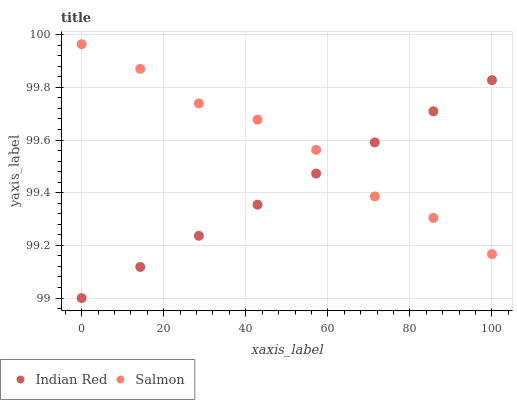Does Indian Red have the minimum area under the curve?
Answer yes or no. Yes. Does Salmon have the maximum area under the curve?
Answer yes or no. Yes. Does Indian Red have the maximum area under the curve?
Answer yes or no. No. Is Indian Red the smoothest?
Answer yes or no. Yes. Is Salmon the roughest?
Answer yes or no. Yes. Is Indian Red the roughest?
Answer yes or no. No. Does Indian Red have the lowest value?
Answer yes or no. Yes. Does Salmon have the highest value?
Answer yes or no. Yes. Does Indian Red have the highest value?
Answer yes or no. No. Does Indian Red intersect Salmon?
Answer yes or no. Yes. Is Indian Red less than Salmon?
Answer yes or no. No. Is Indian Red greater than Salmon?
Answer yes or no. No. 